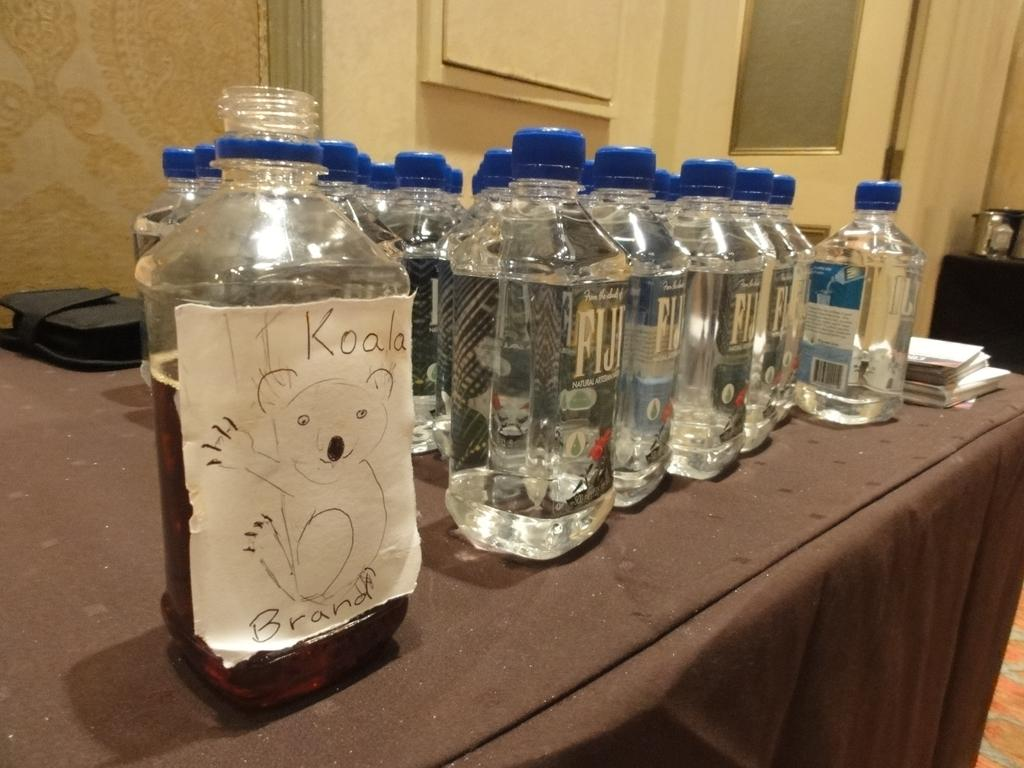<image>
Write a terse but informative summary of the picture. a fake label on a Fiji water bottle named Koala Brand 